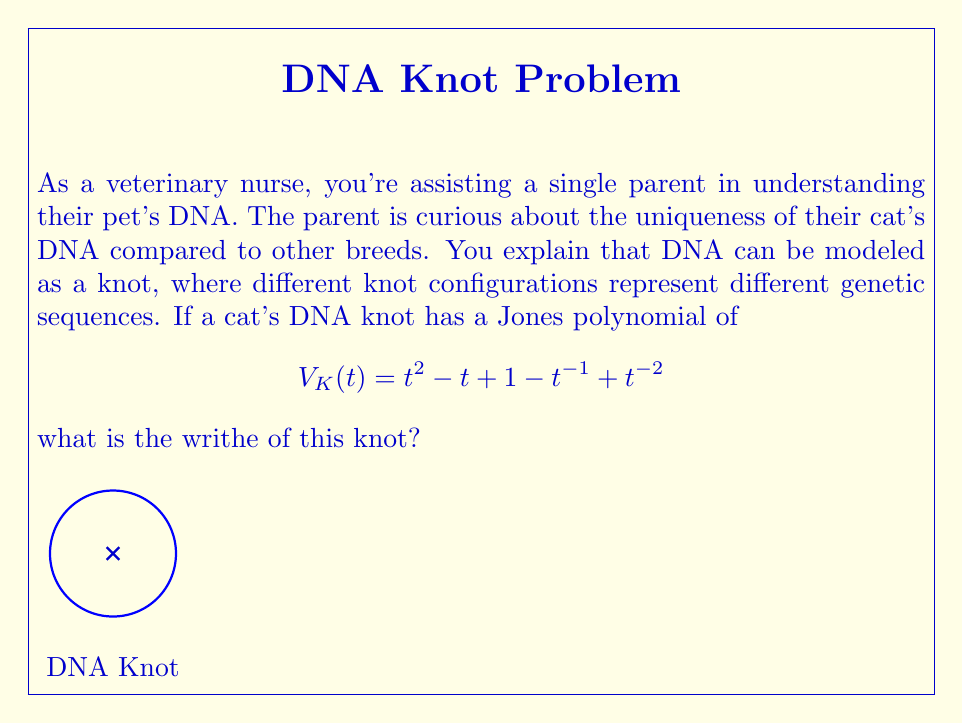Show me your answer to this math problem. To solve this problem, we'll follow these steps:

1) Recall that for any knot K, its Jones polynomial V_K(t) is related to its writhe w(K) by the following formula:

   $$V_K(t) = (-A^{-3})^{w(K)}$$

   where A is defined as $$t = A^{-4}$$.

2) In our case, we're given:

   $$V_K(t) = t^2 - t + 1 - t^{-1} + t^{-2}$$

3) To find the writhe, we need to express this polynomial in the form $$(-A^{-3})^{w(K)}$$.

4) First, let's substitute $$t = A^{-4}$$ into our polynomial:

   $$V_K(A) = (A^{-4})^2 - A^{-4} + 1 - A^4 + (A^{-4})^{-2}$$
   $$= A^{-8} - A^{-4} + 1 - A^4 + A^8$$

5) Now, we need to factor out $$-A^{-3}$$ as many times as possible. Let's start with $$-A^{-3}$$:

   $$-A^{-3}(A^{-5} + A^{-1} - A^3 + A^7 - A^{11})$$

6) We can't factor out $$-A^{-3}$$ anymore, so this means the writhe w(K) is 1.

7) To verify, we can expand $$(-A^{-3})^1 = -A^{-3}$$ and multiply it by $$(A^{-5} + A^{-1} - A^3 + A^7 - A^{11})$$, which indeed gives us our original polynomial.
Answer: 1 